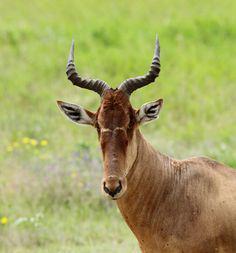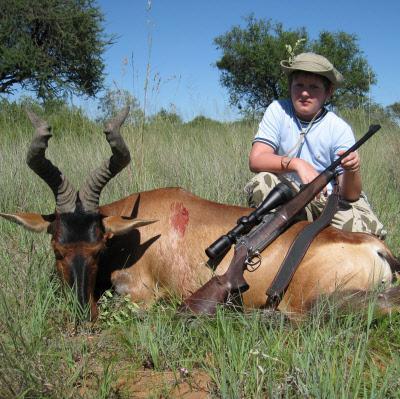The first image is the image on the left, the second image is the image on the right. Analyze the images presented: Is the assertion "Each image includes exactly one upright (standing) horned animal with its body in profile." valid? Answer yes or no. No. 